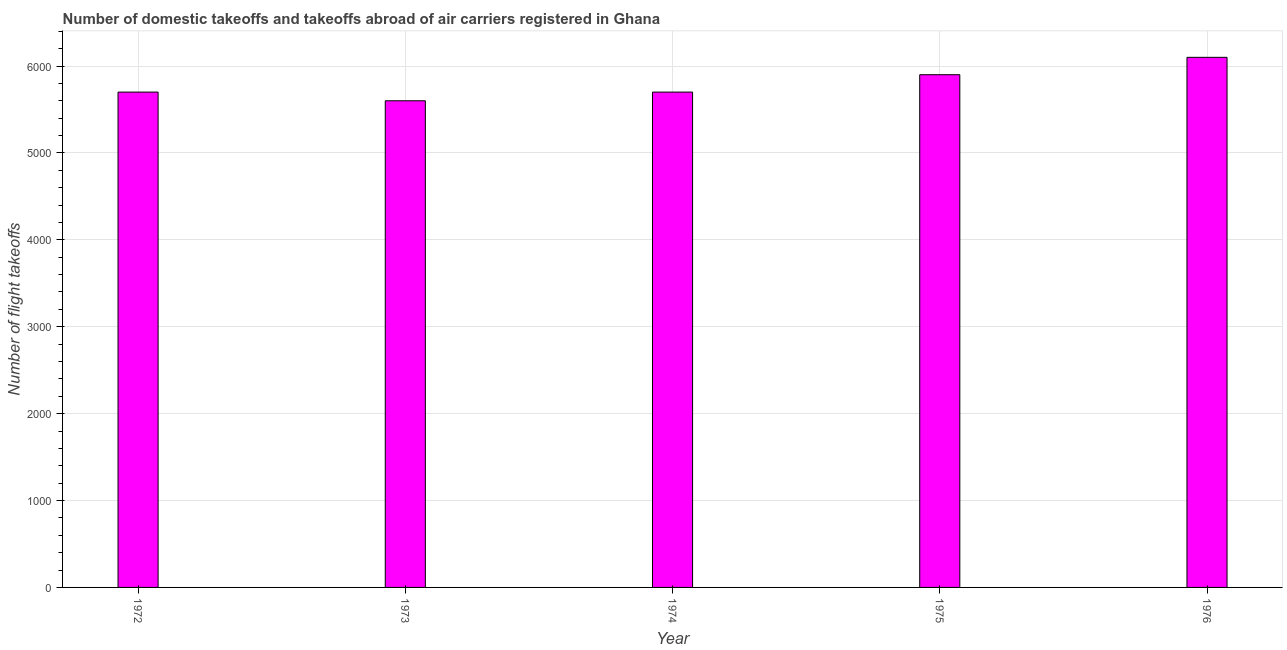What is the title of the graph?
Your response must be concise. Number of domestic takeoffs and takeoffs abroad of air carriers registered in Ghana. What is the label or title of the Y-axis?
Provide a succinct answer. Number of flight takeoffs. What is the number of flight takeoffs in 1973?
Ensure brevity in your answer.  5600. Across all years, what is the maximum number of flight takeoffs?
Make the answer very short. 6100. Across all years, what is the minimum number of flight takeoffs?
Offer a terse response. 5600. In which year was the number of flight takeoffs maximum?
Your answer should be compact. 1976. What is the sum of the number of flight takeoffs?
Ensure brevity in your answer.  2.90e+04. What is the difference between the number of flight takeoffs in 1974 and 1975?
Ensure brevity in your answer.  -200. What is the average number of flight takeoffs per year?
Provide a short and direct response. 5800. What is the median number of flight takeoffs?
Your answer should be compact. 5700. In how many years, is the number of flight takeoffs greater than 5200 ?
Offer a very short reply. 5. What is the ratio of the number of flight takeoffs in 1973 to that in 1976?
Give a very brief answer. 0.92. Is the number of flight takeoffs in 1973 less than that in 1974?
Your response must be concise. Yes. Is the difference between the number of flight takeoffs in 1972 and 1974 greater than the difference between any two years?
Provide a short and direct response. No. How many bars are there?
Your response must be concise. 5. How many years are there in the graph?
Offer a very short reply. 5. What is the difference between two consecutive major ticks on the Y-axis?
Give a very brief answer. 1000. What is the Number of flight takeoffs of 1972?
Make the answer very short. 5700. What is the Number of flight takeoffs of 1973?
Ensure brevity in your answer.  5600. What is the Number of flight takeoffs of 1974?
Offer a terse response. 5700. What is the Number of flight takeoffs in 1975?
Your answer should be compact. 5900. What is the Number of flight takeoffs of 1976?
Provide a short and direct response. 6100. What is the difference between the Number of flight takeoffs in 1972 and 1973?
Make the answer very short. 100. What is the difference between the Number of flight takeoffs in 1972 and 1975?
Your response must be concise. -200. What is the difference between the Number of flight takeoffs in 1972 and 1976?
Keep it short and to the point. -400. What is the difference between the Number of flight takeoffs in 1973 and 1974?
Provide a short and direct response. -100. What is the difference between the Number of flight takeoffs in 1973 and 1975?
Ensure brevity in your answer.  -300. What is the difference between the Number of flight takeoffs in 1973 and 1976?
Provide a succinct answer. -500. What is the difference between the Number of flight takeoffs in 1974 and 1975?
Make the answer very short. -200. What is the difference between the Number of flight takeoffs in 1974 and 1976?
Give a very brief answer. -400. What is the difference between the Number of flight takeoffs in 1975 and 1976?
Make the answer very short. -200. What is the ratio of the Number of flight takeoffs in 1972 to that in 1974?
Give a very brief answer. 1. What is the ratio of the Number of flight takeoffs in 1972 to that in 1976?
Offer a very short reply. 0.93. What is the ratio of the Number of flight takeoffs in 1973 to that in 1975?
Give a very brief answer. 0.95. What is the ratio of the Number of flight takeoffs in 1973 to that in 1976?
Make the answer very short. 0.92. What is the ratio of the Number of flight takeoffs in 1974 to that in 1976?
Provide a short and direct response. 0.93. What is the ratio of the Number of flight takeoffs in 1975 to that in 1976?
Ensure brevity in your answer.  0.97. 